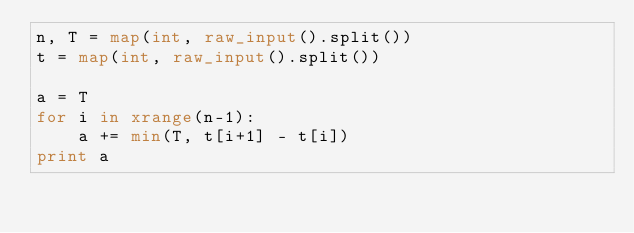<code> <loc_0><loc_0><loc_500><loc_500><_Python_>n, T = map(int, raw_input().split())
t = map(int, raw_input().split())

a = T
for i in xrange(n-1):
    a += min(T, t[i+1] - t[i])
print a</code> 